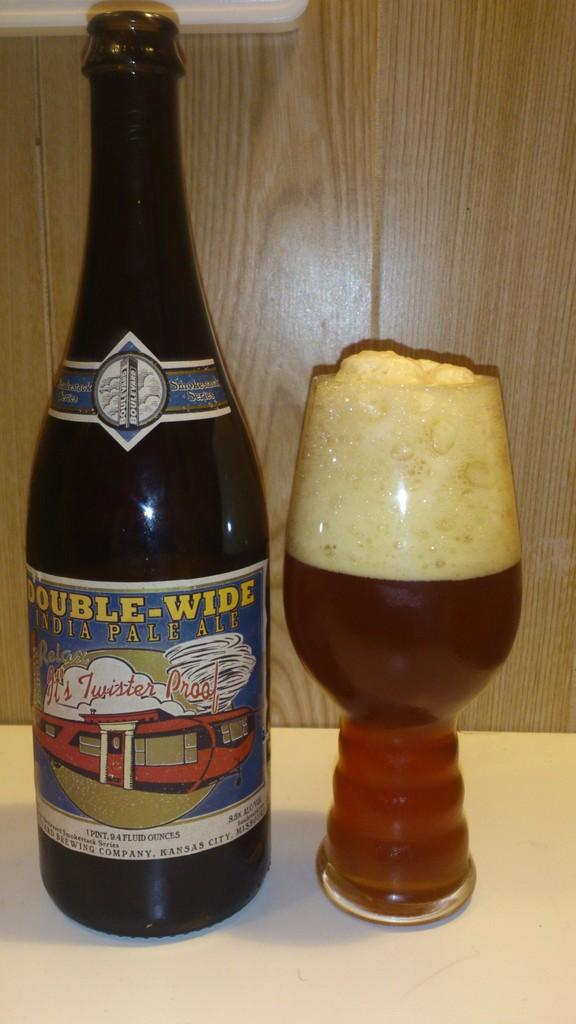<image>
Describe the image concisely. A bottle of Double-Wide India pale ale sits next to a glass of beer. 